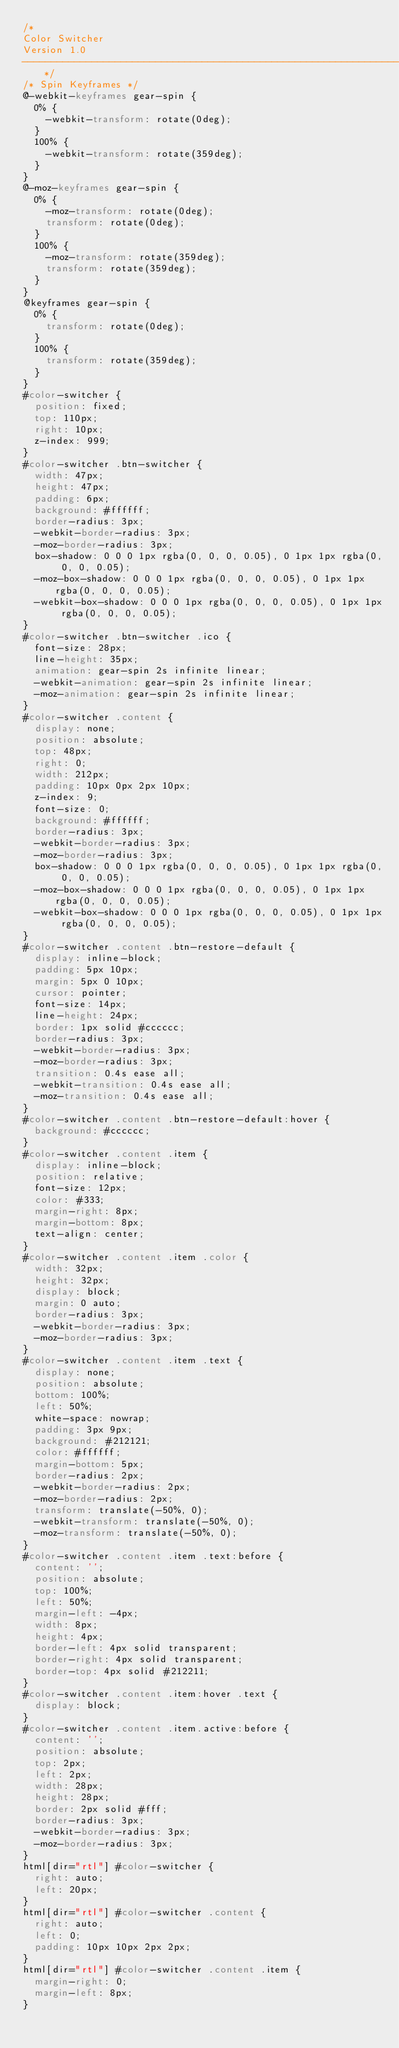Convert code to text. <code><loc_0><loc_0><loc_500><loc_500><_CSS_>/*
Color Switcher
Version 1.0
-------------------------------------------------------------------------*/
/* Spin Keyframes */
@-webkit-keyframes gear-spin {
  0% {
    -webkit-transform: rotate(0deg);
  }
  100% {
    -webkit-transform: rotate(359deg);
  }
}
@-moz-keyframes gear-spin {
  0% {
    -moz-transform: rotate(0deg);
    transform: rotate(0deg);
  }
  100% {
    -moz-transform: rotate(359deg);
    transform: rotate(359deg);
  }
}
@keyframes gear-spin {
  0% {
    transform: rotate(0deg);
  }
  100% {
    transform: rotate(359deg);
  }
}
#color-switcher {
  position: fixed;
  top: 110px;
  right: 10px;
  z-index: 999;
}
#color-switcher .btn-switcher {
  width: 47px;
  height: 47px;
  padding: 6px;
  background: #ffffff;
  border-radius: 3px;
  -webkit-border-radius: 3px;
  -moz-border-radius: 3px;
  box-shadow: 0 0 0 1px rgba(0, 0, 0, 0.05), 0 1px 1px rgba(0, 0, 0, 0.05);
  -moz-box-shadow: 0 0 0 1px rgba(0, 0, 0, 0.05), 0 1px 1px rgba(0, 0, 0, 0.05);
  -webkit-box-shadow: 0 0 0 1px rgba(0, 0, 0, 0.05), 0 1px 1px rgba(0, 0, 0, 0.05);
}
#color-switcher .btn-switcher .ico {
  font-size: 28px;
  line-height: 35px;
  animation: gear-spin 2s infinite linear;
  -webkit-animation: gear-spin 2s infinite linear;
  -moz-animation: gear-spin 2s infinite linear;
}
#color-switcher .content {
  display: none;
  position: absolute;
  top: 48px;
  right: 0;
  width: 212px;
  padding: 10px 0px 2px 10px;
  z-index: 9;
  font-size: 0;
  background: #ffffff;
  border-radius: 3px;
  -webkit-border-radius: 3px;
  -moz-border-radius: 3px;
  box-shadow: 0 0 0 1px rgba(0, 0, 0, 0.05), 0 1px 1px rgba(0, 0, 0, 0.05);
  -moz-box-shadow: 0 0 0 1px rgba(0, 0, 0, 0.05), 0 1px 1px rgba(0, 0, 0, 0.05);
  -webkit-box-shadow: 0 0 0 1px rgba(0, 0, 0, 0.05), 0 1px 1px rgba(0, 0, 0, 0.05);
}
#color-switcher .content .btn-restore-default {
  display: inline-block;
  padding: 5px 10px;
  margin: 5px 0 10px;
  cursor: pointer;
  font-size: 14px;
  line-height: 24px;
  border: 1px solid #cccccc;
  border-radius: 3px;
  -webkit-border-radius: 3px;
  -moz-border-radius: 3px;
  transition: 0.4s ease all;
  -webkit-transition: 0.4s ease all;
  -moz-transition: 0.4s ease all;
}
#color-switcher .content .btn-restore-default:hover {
  background: #cccccc;
}
#color-switcher .content .item {
  display: inline-block;
  position: relative;
  font-size: 12px;
  color: #333;
  margin-right: 8px;
  margin-bottom: 8px;
  text-align: center;
}
#color-switcher .content .item .color {
  width: 32px;
  height: 32px;
  display: block;
  margin: 0 auto;
  border-radius: 3px;
  -webkit-border-radius: 3px;
  -moz-border-radius: 3px;
}
#color-switcher .content .item .text {
  display: none;
  position: absolute;
  bottom: 100%;
  left: 50%;
  white-space: nowrap;
  padding: 3px 9px;
  background: #212121;
  color: #ffffff;
  margin-bottom: 5px;
  border-radius: 2px;
  -webkit-border-radius: 2px;
  -moz-border-radius: 2px;
  transform: translate(-50%, 0);
  -webkit-transform: translate(-50%, 0);
  -moz-transform: translate(-50%, 0);
}
#color-switcher .content .item .text:before {
  content: '';
  position: absolute;
  top: 100%;
  left: 50%;
  margin-left: -4px;
  width: 8px;
  height: 4px;
  border-left: 4px solid transparent;
  border-right: 4px solid transparent;
  border-top: 4px solid #212211;
}
#color-switcher .content .item:hover .text {
  display: block;
}
#color-switcher .content .item.active:before {
  content: '';
  position: absolute;
  top: 2px;
  left: 2px;
  width: 28px;
  height: 28px;
  border: 2px solid #fff;
  border-radius: 3px;
  -webkit-border-radius: 3px;
  -moz-border-radius: 3px;
}
html[dir="rtl"] #color-switcher {
  right: auto;
  left: 20px;
}
html[dir="rtl"] #color-switcher .content {
  right: auto;
  left: 0;
  padding: 10px 10px 2px 2px;
}
html[dir="rtl"] #color-switcher .content .item {
  margin-right: 0;
  margin-left: 8px;
}
</code> 